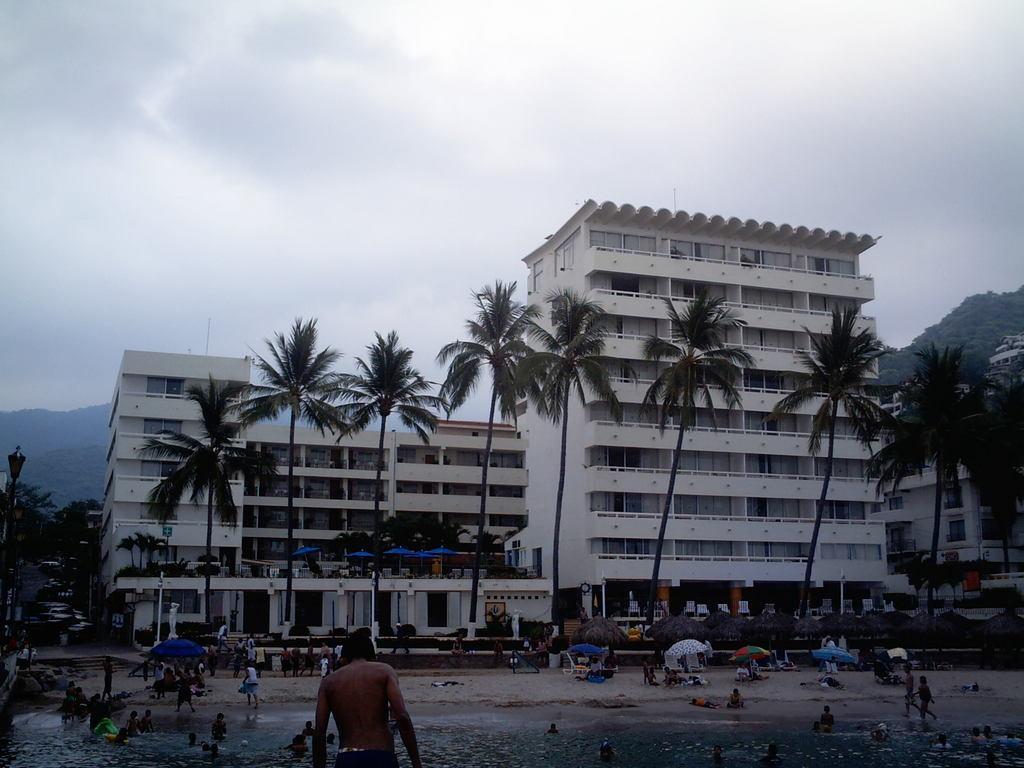Describe this image in one or two sentences. At the bottom of the image I can see a beach. There are many people in the water and also few people sitting under the umbrellas on the beach. In the background, I can see many trees and buildings. At the top of the image I can see the sky. 